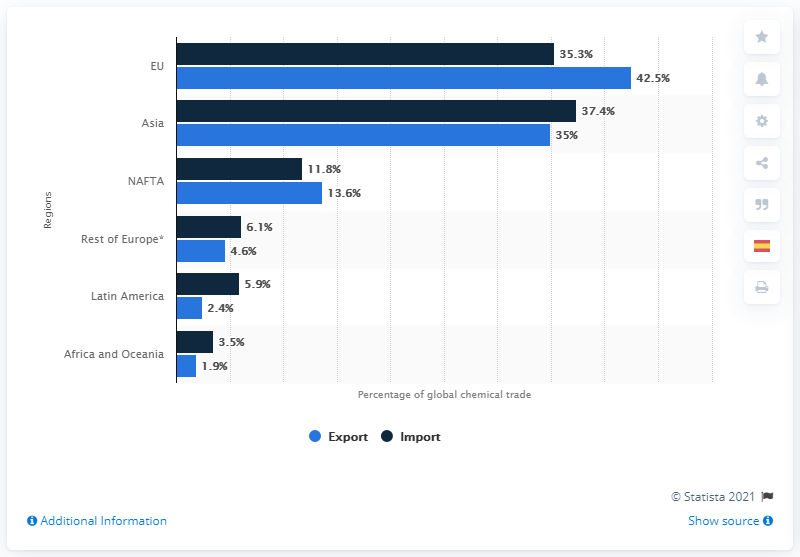Identify some key points in this picture. The European Union had the highest level of exports. According to data from Asia, the average of exports and imports is 36.2. 